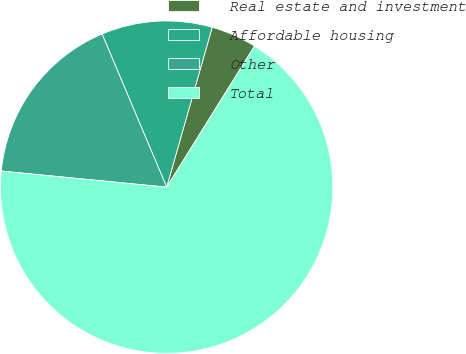Convert chart to OTSL. <chart><loc_0><loc_0><loc_500><loc_500><pie_chart><fcel>Real estate and investment<fcel>Affordable housing<fcel>Other<fcel>Total<nl><fcel>4.45%<fcel>10.77%<fcel>17.1%<fcel>67.68%<nl></chart> 